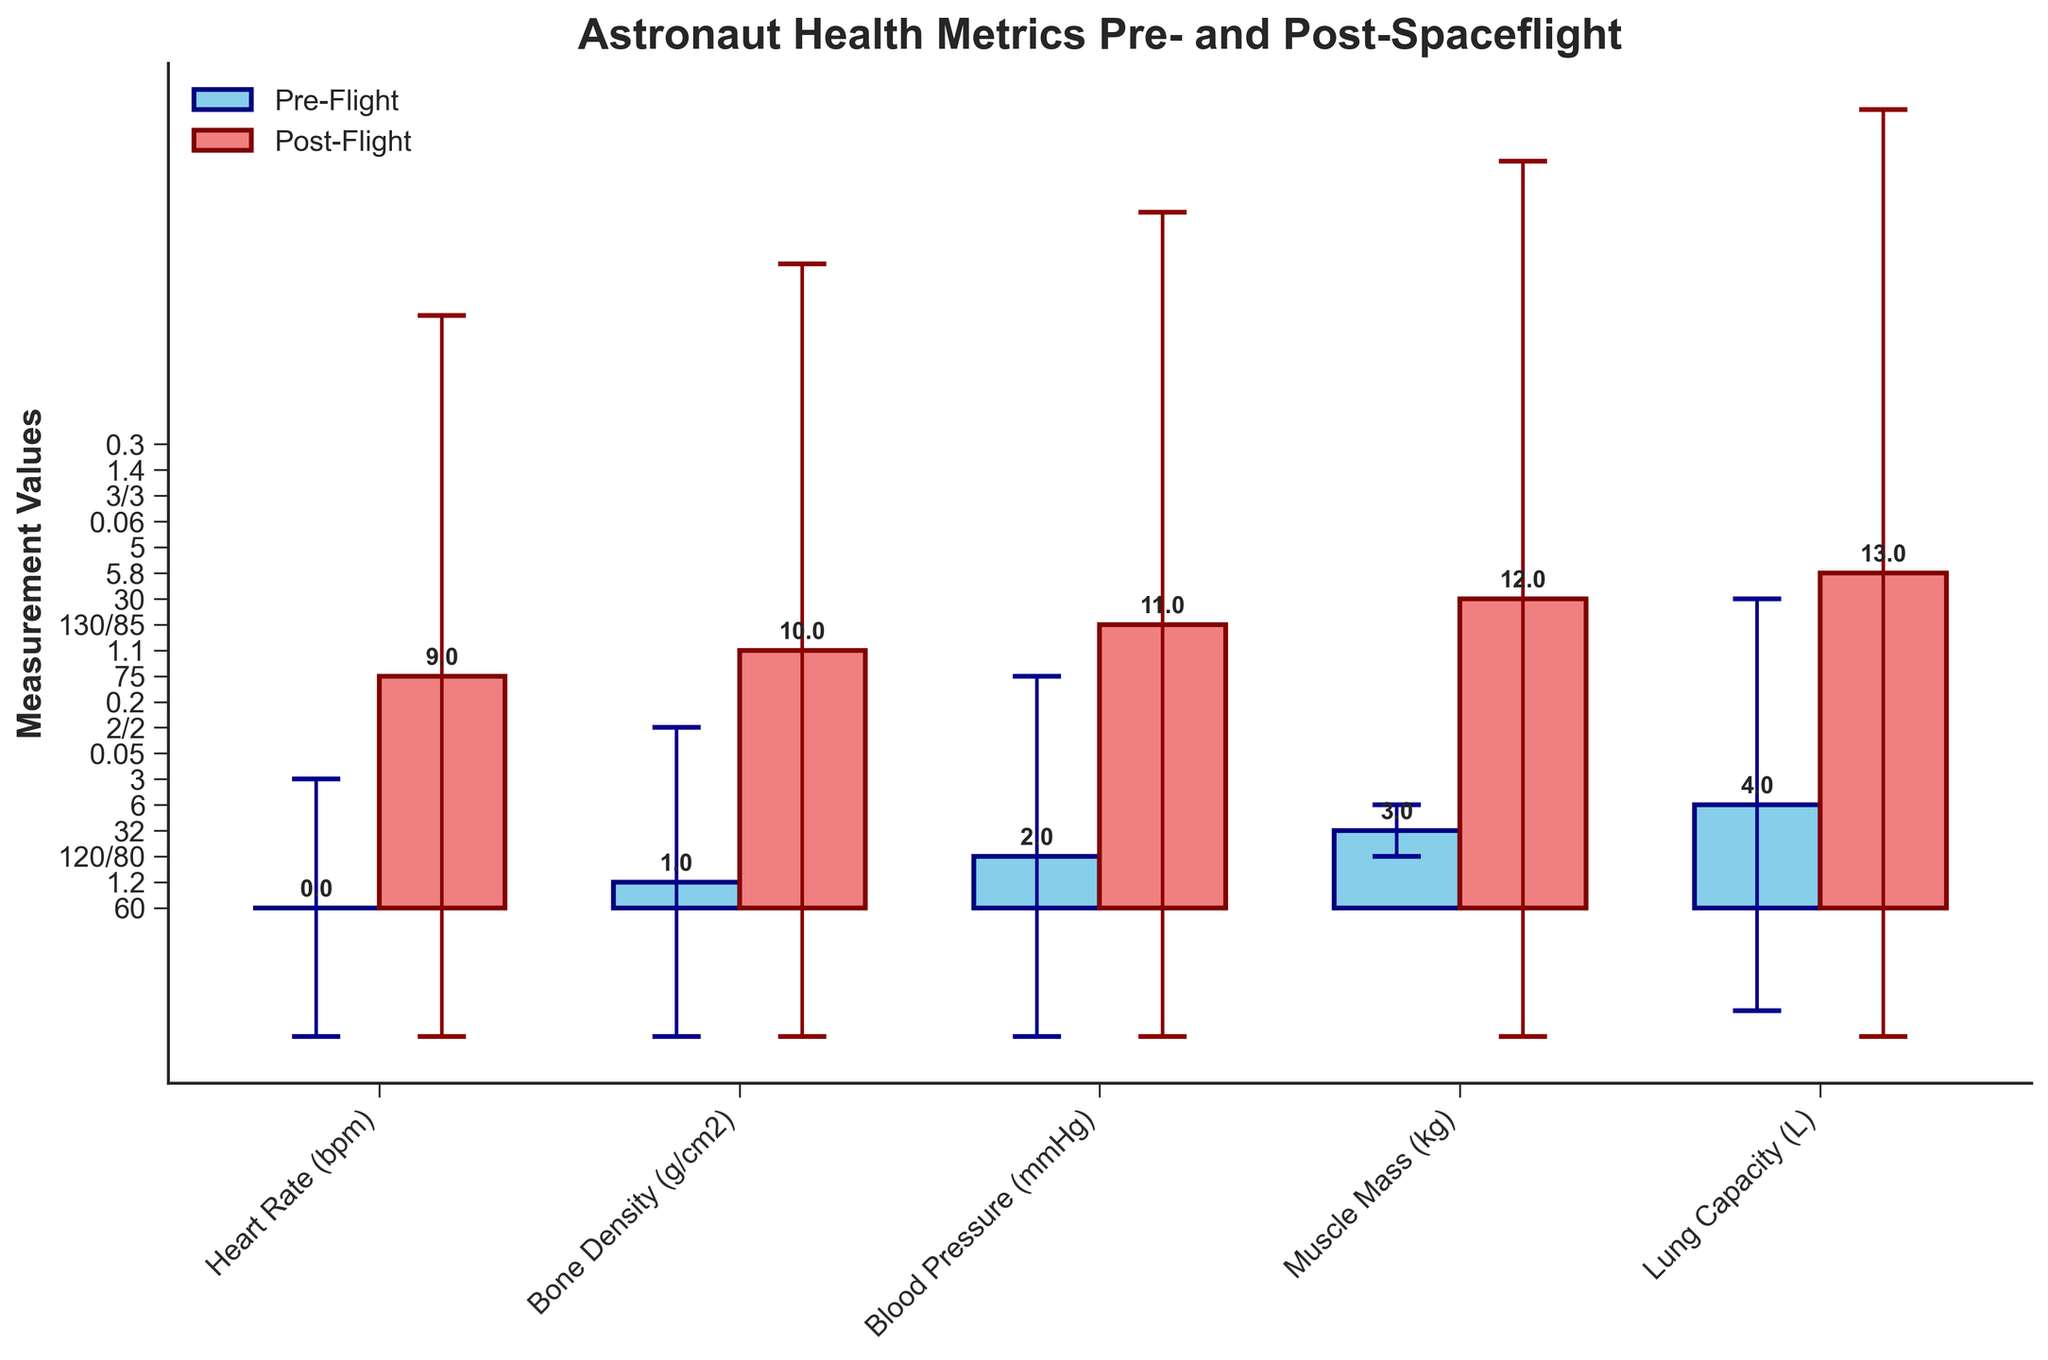What's the title of the plot? The title is located at the top of the plot in a font size larger compared to the other texts. It describes the data being visualized.
Answer: Astronaut Health Metrics Pre- and Post-Spaceflight What are the units for the Muscle Mass metric? The units for Muscle Mass are indicated next to the name of the metric along the x-axis. In this case, it's measured in kilograms (kg).
Answer: kg How many astronaut metrics are being observed in the figure? Each bar represents a different metric, and we can count the unique labels along the x-axis to determine the number of metrics.
Answer: 5 Which metric shows the greatest change from pre-flight to post-flight? By comparing the differences between the heights of the pre-flight (blue) and post-flight (red) bars, we identify that Heart Rate (bpm) shows the most significant increase from 60 to 75.
Answer: Heart Rate (bpm) Does any metric show a decrease in post-flight readings? Evaluating the heights of the pre-flight and post-flight bars, we see that Bone Density (g/cm2) and Muscle Mass (kg) decrease in their post-flight measurements.
Answer: Yes Which metric has the largest error range for post-flight measurements? The error bars atop the post-flight (red) bars indicate the uncertainty range. Muscle Mass (kg) has the largest error range of 1.4.
Answer: Muscle Mass (kg) What is the pre-flight measurement of Jane Smith's Bone Density? Locate the bar labeled Bone Density (g/cm2) under the pre-flight segment (blue bar) to find the value.
Answer: 1.2 g/cm2 By how much did Alex Black's Muscle Mass change after the flight? Subtract the post-flight value (30 kg) from the pre-flight value (32 kg) to find the change in Muscle Mass.
Answer: 2 kg decrease Which metric has the smallest error range for pre-flight measurements? Examine the error bars for the pre-flight segment and identify Blood Pressure (mmHg) with an error range of 2/2 as the smallest.
Answer: Blood Pressure (mmHg) Compare the post-flight lung capacity measurement to the pre-flight one. Is it higher, lower, or the same? The heights of the lung capacity bars show that post-flight lung capacity (5.8 L) is slightly lower than the pre-flight capacity (6 L).
Answer: Lower 